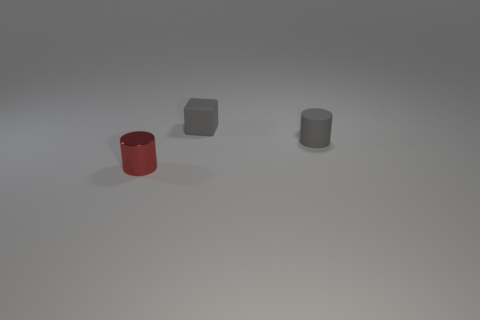Add 1 big blue metal balls. How many objects exist? 4 Subtract 1 cylinders. How many cylinders are left? 1 Add 3 small gray rubber cylinders. How many small gray rubber cylinders exist? 4 Subtract 0 yellow cylinders. How many objects are left? 3 Subtract all cubes. How many objects are left? 2 Subtract all blue cubes. Subtract all blue cylinders. How many cubes are left? 1 Subtract all green spheres. How many gray cylinders are left? 1 Subtract all large cyan shiny spheres. Subtract all cylinders. How many objects are left? 1 Add 2 gray blocks. How many gray blocks are left? 3 